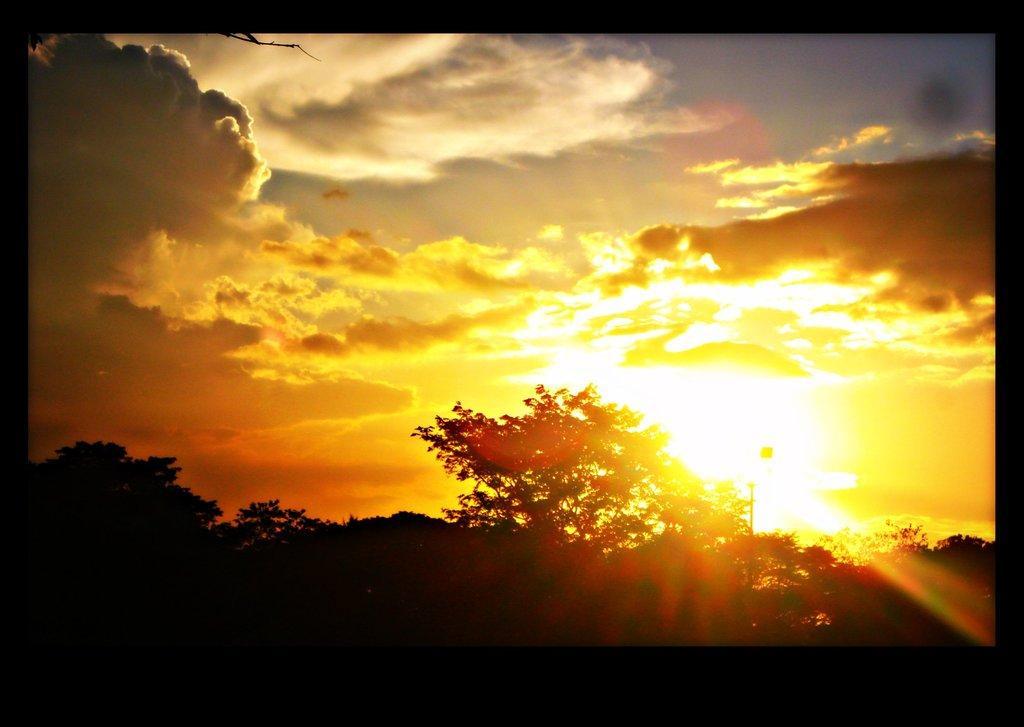Can you describe this image briefly? In this image there are trees at the ground also there are clouds and sun at the sky. 